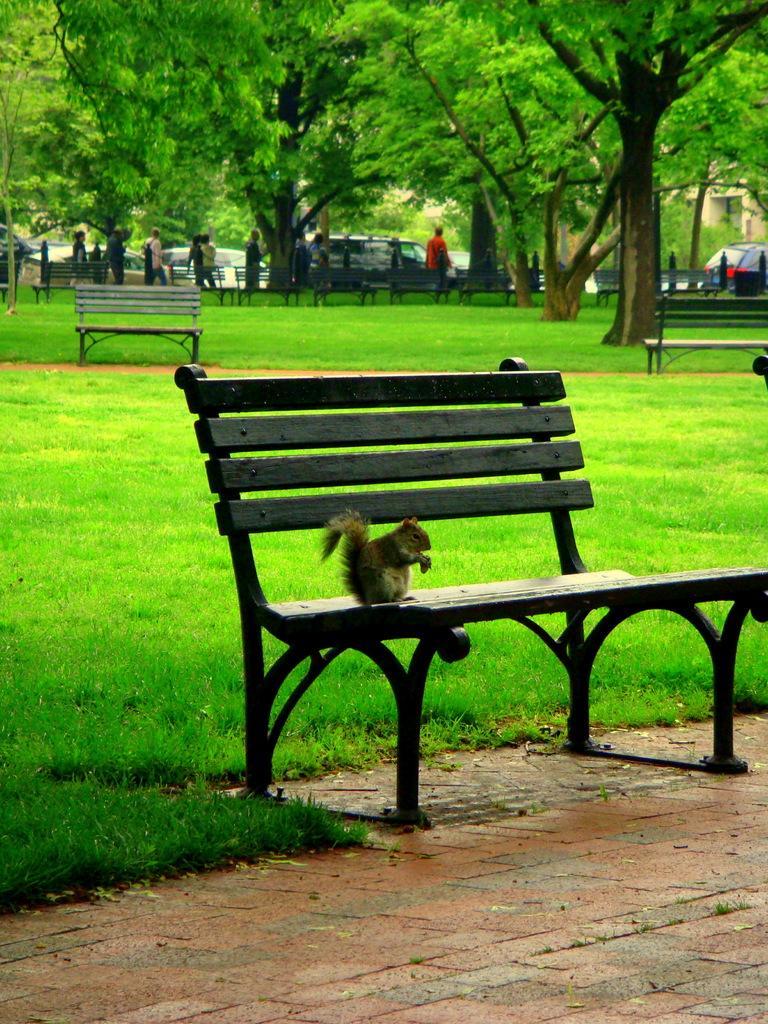How would you summarize this image in a sentence or two? In this image I can see a bench in the front and on it I can see a squirrel. In the background I can see an open grass ground, number of benches, number of trees, few vehicles and I can also see number of people are standing on the ground. 